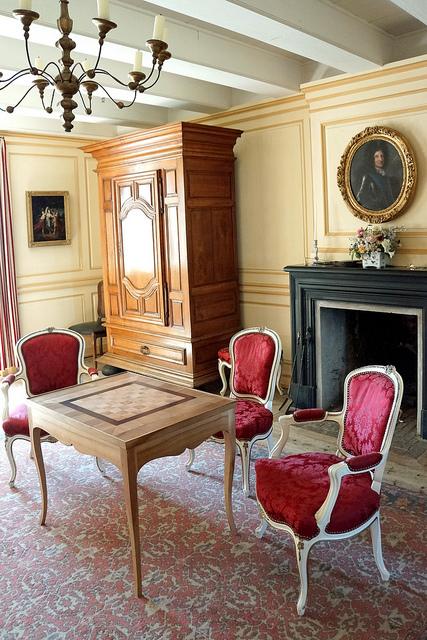How is this room being lit?
Concise answer only. Sunlight. How many red chairs are in the room?
Short answer required. 3. Are the chairs fancy?
Quick response, please. Yes. 